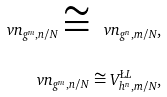Convert formula to latex. <formula><loc_0><loc_0><loc_500><loc_500>\ v n _ { g ^ { m } , n / N } \cong \ v n _ { g ^ { n } , m / N } , \\ \ v n _ { g ^ { m } , n / N } \cong V ^ { \L L } _ { h ^ { n } , m / N } ,</formula> 